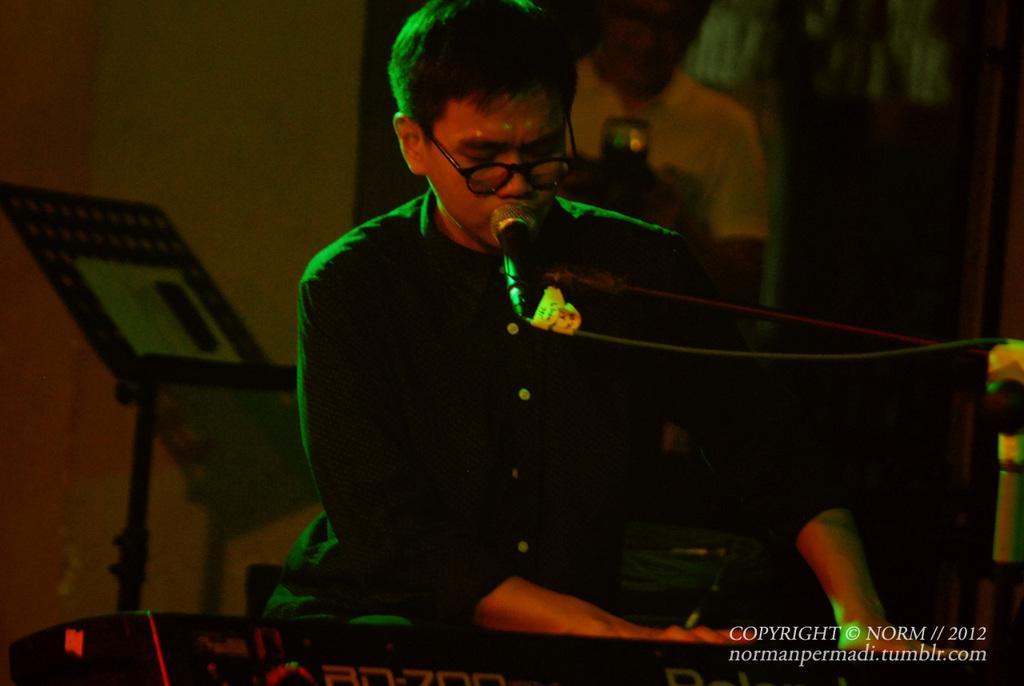Could you give a brief overview of what you see in this image? This image consists of a person's singing and playing a piano. In the background, we can see another person. On the left, there is a book stand. In the background, we can see a wall. On the right, there is a mic stand. 